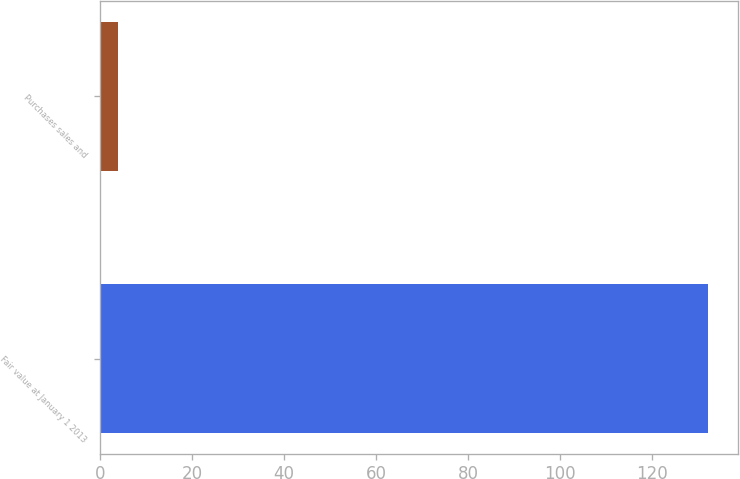Convert chart to OTSL. <chart><loc_0><loc_0><loc_500><loc_500><bar_chart><fcel>Fair value at January 1 2013<fcel>Purchases sales and<nl><fcel>132<fcel>4<nl></chart> 